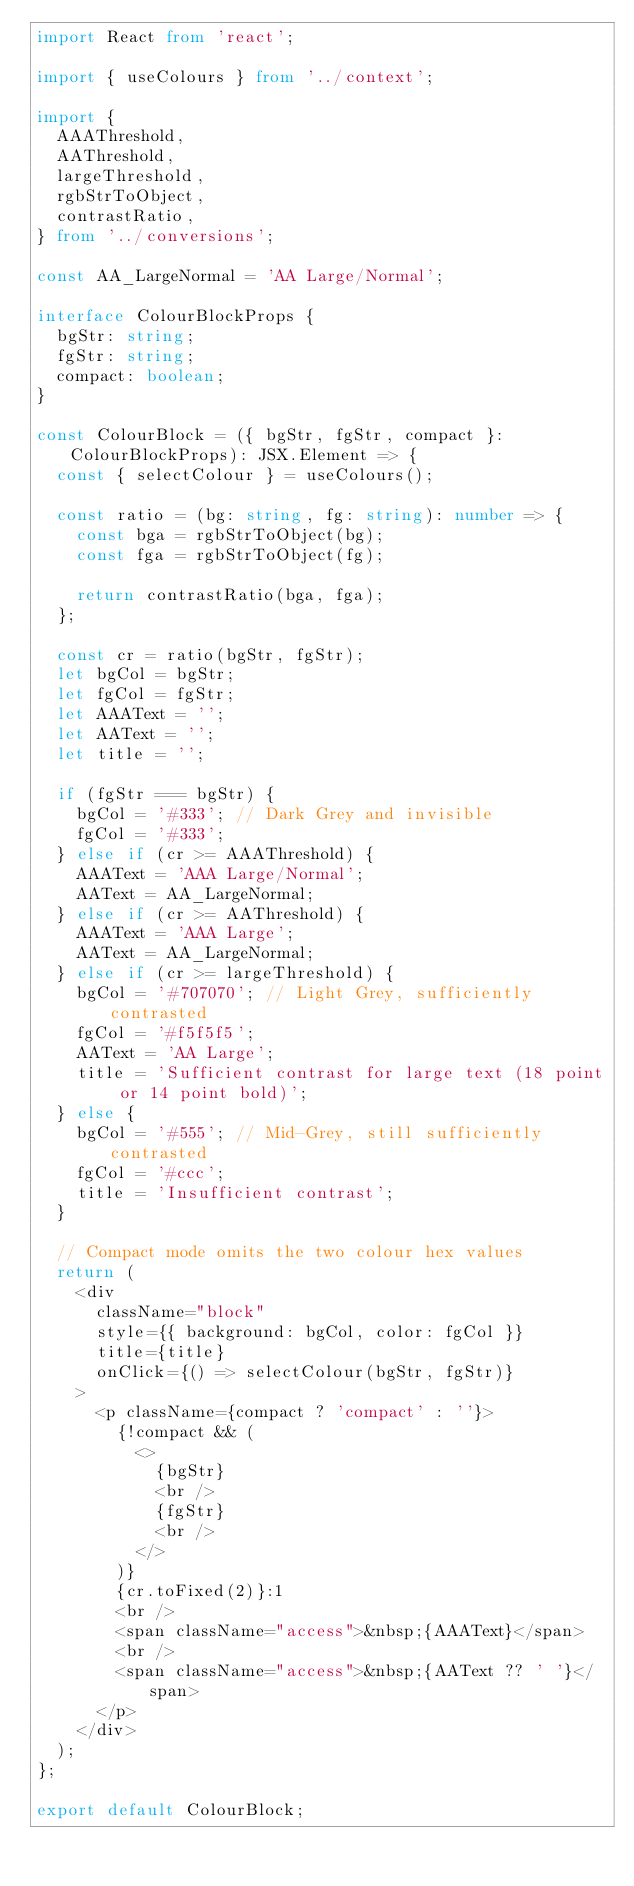<code> <loc_0><loc_0><loc_500><loc_500><_TypeScript_>import React from 'react';

import { useColours } from '../context';

import {
  AAAThreshold,
  AAThreshold,
  largeThreshold,
  rgbStrToObject,
  contrastRatio,
} from '../conversions';

const AA_LargeNormal = 'AA Large/Normal';

interface ColourBlockProps {
  bgStr: string;
  fgStr: string;
  compact: boolean;
}

const ColourBlock = ({ bgStr, fgStr, compact }: ColourBlockProps): JSX.Element => {
  const { selectColour } = useColours();

  const ratio = (bg: string, fg: string): number => {
    const bga = rgbStrToObject(bg);
    const fga = rgbStrToObject(fg);

    return contrastRatio(bga, fga);
  };

  const cr = ratio(bgStr, fgStr);
  let bgCol = bgStr;
  let fgCol = fgStr;
  let AAAText = '';
  let AAText = '';
  let title = '';

  if (fgStr === bgStr) {
    bgCol = '#333'; // Dark Grey and invisible
    fgCol = '#333';
  } else if (cr >= AAAThreshold) {
    AAAText = 'AAA Large/Normal';
    AAText = AA_LargeNormal;
  } else if (cr >= AAThreshold) {
    AAAText = 'AAA Large';
    AAText = AA_LargeNormal;
  } else if (cr >= largeThreshold) {
    bgCol = '#707070'; // Light Grey, sufficiently contrasted
    fgCol = '#f5f5f5';
    AAText = 'AA Large';
    title = 'Sufficient contrast for large text (18 point or 14 point bold)';
  } else {
    bgCol = '#555'; // Mid-Grey, still sufficiently contrasted
    fgCol = '#ccc';
    title = 'Insufficient contrast';
  }

  // Compact mode omits the two colour hex values
  return (
    <div
      className="block"
      style={{ background: bgCol, color: fgCol }}
      title={title}
      onClick={() => selectColour(bgStr, fgStr)}
    >
      <p className={compact ? 'compact' : ''}>
        {!compact && (
          <>
            {bgStr}
            <br />
            {fgStr}
            <br />
          </>
        )}
        {cr.toFixed(2)}:1
        <br />
        <span className="access">&nbsp;{AAAText}</span>
        <br />
        <span className="access">&nbsp;{AAText ?? ' '}</span>
      </p>
    </div>
  );
};

export default ColourBlock;
</code> 